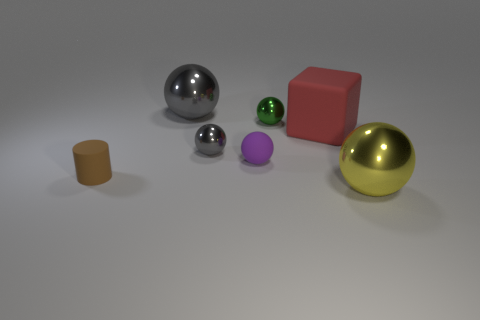Are there more tiny brown cylinders behind the small rubber cylinder than big red matte blocks that are left of the red matte thing?
Keep it short and to the point. No. How many other things are the same size as the red object?
Provide a succinct answer. 2. Are there more small brown cylinders in front of the tiny matte sphere than big gray rubber cubes?
Provide a short and direct response. Yes. Is there anything else of the same color as the large matte object?
Provide a short and direct response. No. What shape is the gray metal object in front of the green metal object that is to the right of the tiny brown thing?
Make the answer very short. Sphere. Is the number of cubes greater than the number of tiny brown shiny cylinders?
Give a very brief answer. Yes. What number of big things are both to the right of the small green metallic ball and behind the big yellow thing?
Offer a terse response. 1. There is a large sphere on the right side of the purple rubber ball; how many objects are left of it?
Provide a succinct answer. 6. What number of things are either large shiny spheres that are behind the large red matte object or metal balls that are to the right of the purple thing?
Your response must be concise. 3. There is a small purple thing that is the same shape as the yellow metal thing; what is its material?
Offer a very short reply. Rubber. 